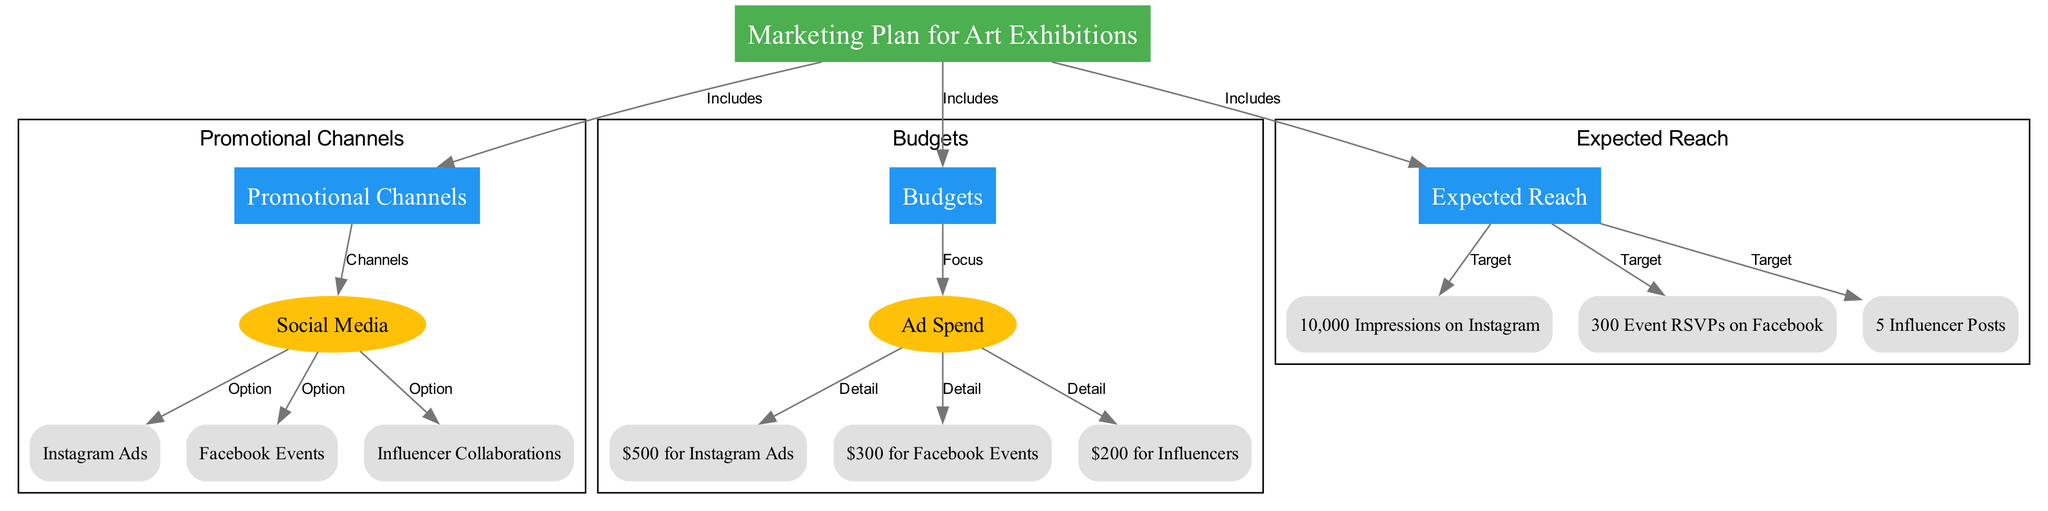What are the three main sections in the marketing plan diagram? The diagram contains three main sections: Promotional Channels, Budgets, and Expected Reach. These are highlighted in boxes as central themes of the diagram.
Answer: Promotional Channels, Budgets, Expected Reach How much is allocated for Instagram Ads? The diagram shows a budget detail for Instagram Ads indicating an allocation of $500. This is derived from the Budgets section.
Answer: $500 What is the total expected reach from the diagram? Based on the Expected Reach section, the impressions and responses add up to a total of 10,000 from Instagram, 300 from Facebook Events, and 5 influencer posts, indicating a broad outreach strategy.
Answer: 10,000 Impressions on Instagram How many promotional channels are listed in the diagram? There are four promotional channels in the diagram: Social Media, Instagram Ads, Facebook Events, and Influencer Collaborations. Each is connected under the Promotional Channels section.
Answer: 4 What is the budget detail for Facebook Events? The diagram specifies a budget detail of $300 allocated for Facebook Events, as indicated in the Budgets section.
Answer: $300 Which promotional channel targets event RSVPs? The Facebook Events channel within the Promotional Channels section specifically targets event RSVPs, as indicated by its expected reach.
Answer: Facebook Events What color represents the Budgets section in the diagram? The Budgets section is represented in blue (#2196F3), which visually distinguishes it from other sections like Promotional Channels and Expected Reach.
Answer: Blue Which node illustrates the expected reach from influencer collaborations? The influencer collaborations target 5 influencer posts as noted in the Expected Reach section, highlighting the effectiveness of this channel.
Answer: 5 Influencer Posts How many edges connect the Promotional Channels to the Budget section? There are three edges connecting the Promotional Channels section to the Budget section, indicating the financial details of three promotional options.
Answer: 3 